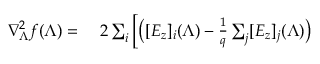Convert formula to latex. <formula><loc_0><loc_0><loc_500><loc_500>\begin{array} { r l } { \nabla _ { \Lambda } ^ { 2 } f ( \Lambda ) = } & \, 2 \sum _ { i } \left [ \left ( [ E _ { z } ] _ { i } ( \Lambda ) - \frac { 1 } { q } \sum _ { j } [ E _ { z } ] _ { j } ( \Lambda ) \right ) } \end{array}</formula> 